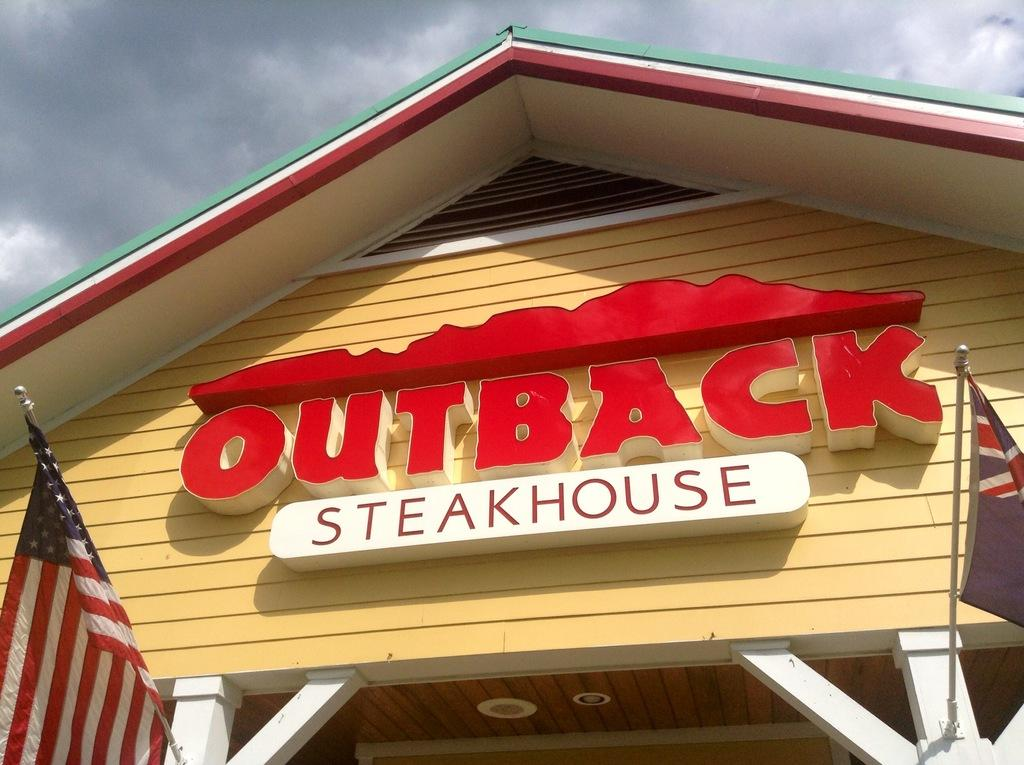What is on the wall in the image? There is a name board on the wall in the image. What else can be seen in the image besides the name board? There are flags and some objects in the image. What is visible in the background of the image? The sky is visible in the background of the image. What type of elbow is visible in the image? There is no elbow present in the image. Are there any curtains visible in the image? There is no mention of curtains in the provided facts, and therefore we cannot determine if any are present in the image. 